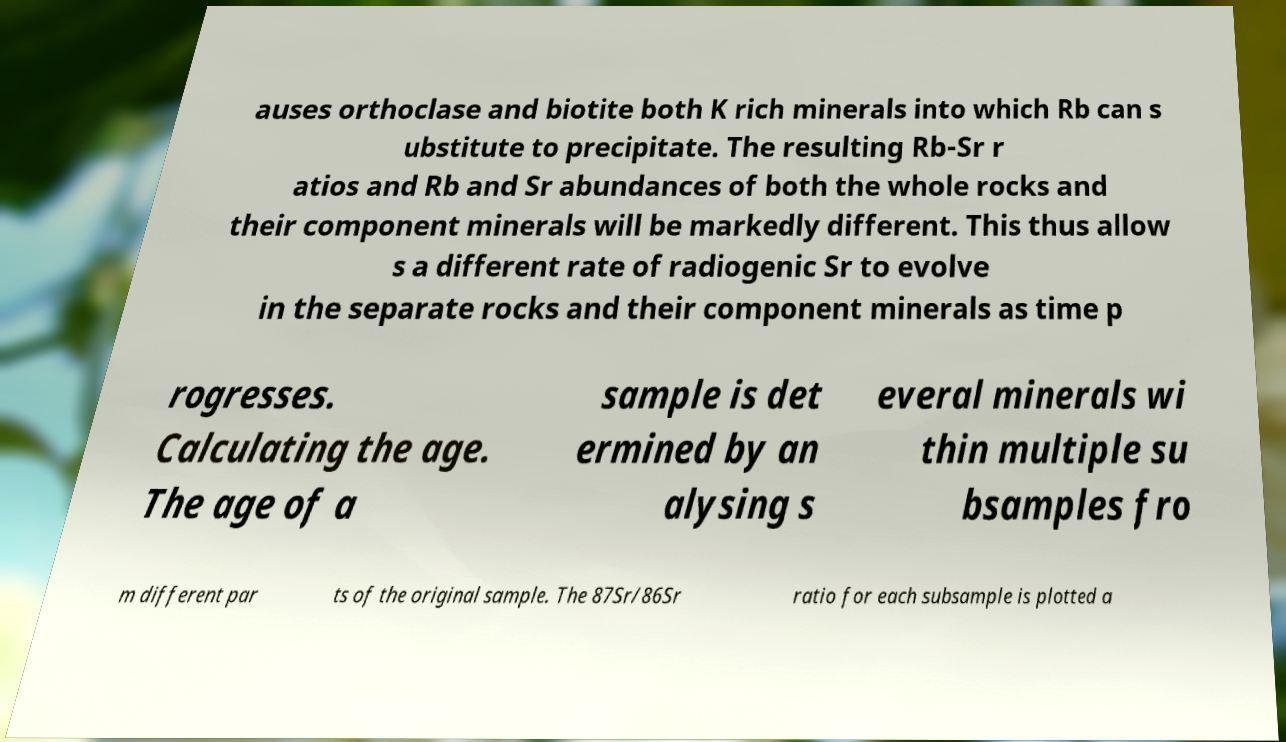Can you accurately transcribe the text from the provided image for me? auses orthoclase and biotite both K rich minerals into which Rb can s ubstitute to precipitate. The resulting Rb-Sr r atios and Rb and Sr abundances of both the whole rocks and their component minerals will be markedly different. This thus allow s a different rate of radiogenic Sr to evolve in the separate rocks and their component minerals as time p rogresses. Calculating the age. The age of a sample is det ermined by an alysing s everal minerals wi thin multiple su bsamples fro m different par ts of the original sample. The 87Sr/86Sr ratio for each subsample is plotted a 